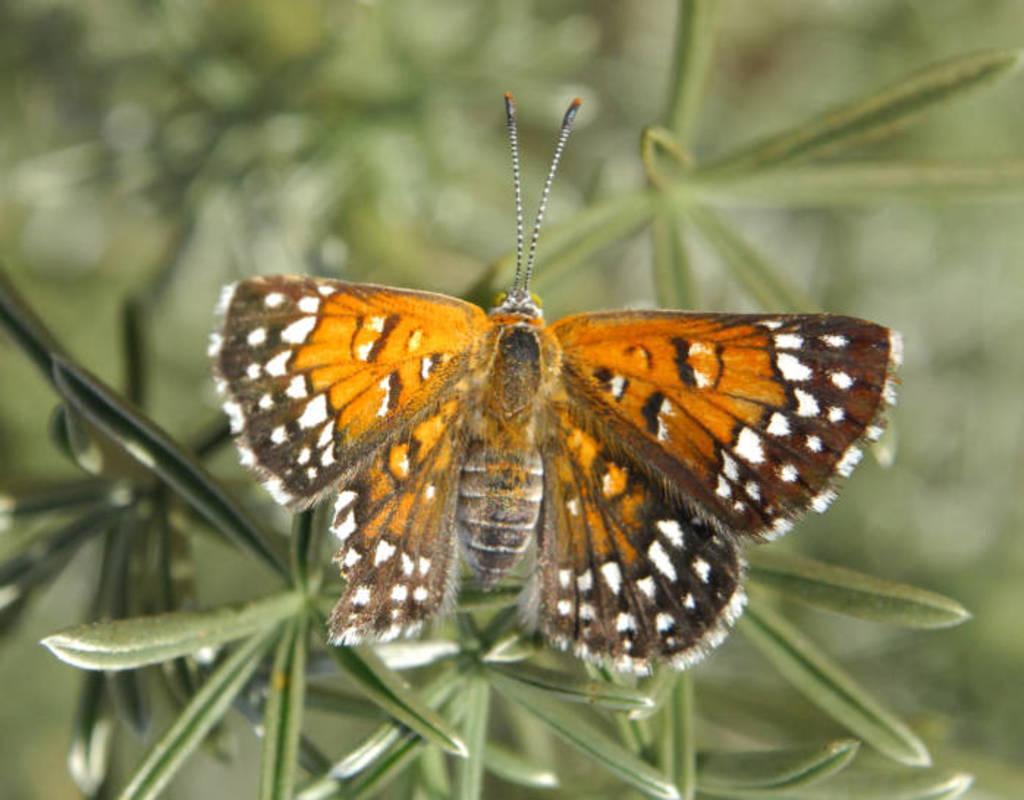Please provide a concise description of this image. There is a butterfly in brown and orange color combination on the leaf of a plant which is having green color leaves. And the background is blurred. 